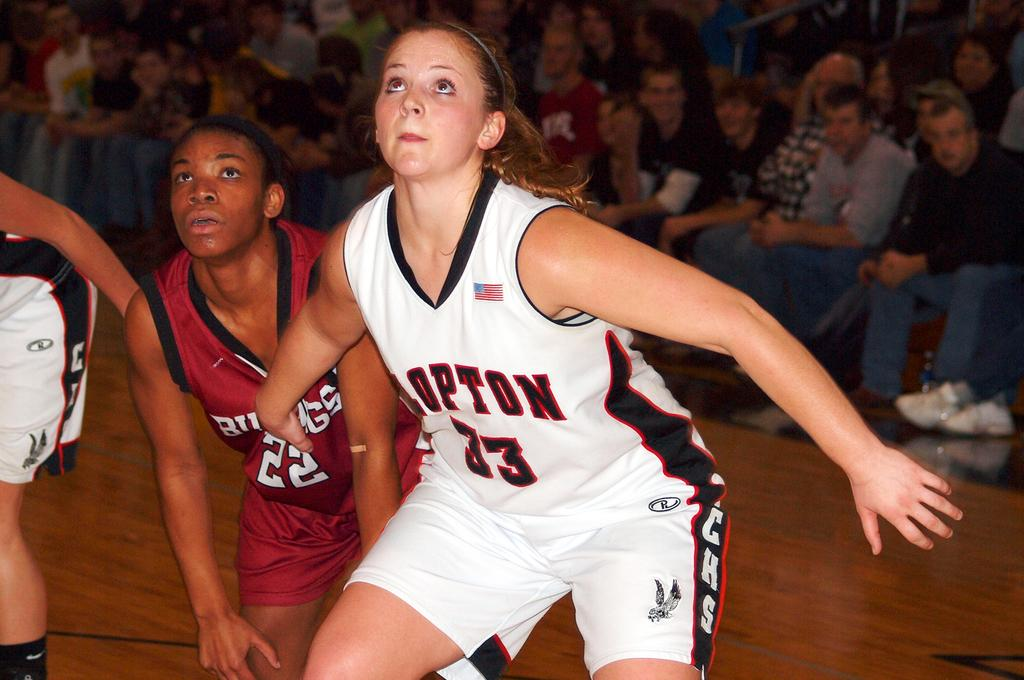<image>
Write a terse but informative summary of the picture. A young woman playing sports, she has the number 33 on her shirt. 